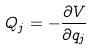<formula> <loc_0><loc_0><loc_500><loc_500>Q _ { j } = - \frac { \partial V } { \partial q _ { j } }</formula> 